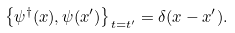Convert formula to latex. <formula><loc_0><loc_0><loc_500><loc_500>\left \{ \psi ^ { \dagger } ( x ) , \psi ( x ^ { \prime } ) \right \} _ { t = t ^ { \prime } } = \delta ( { x } - { x } ^ { \prime } ) .</formula> 